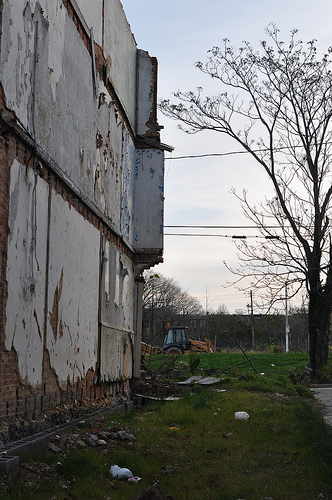<image>
Can you confirm if the building is to the right of the tree? No. The building is not to the right of the tree. The horizontal positioning shows a different relationship. Where is the wire in relation to the building? Is it in front of the building? Yes. The wire is positioned in front of the building, appearing closer to the camera viewpoint. 